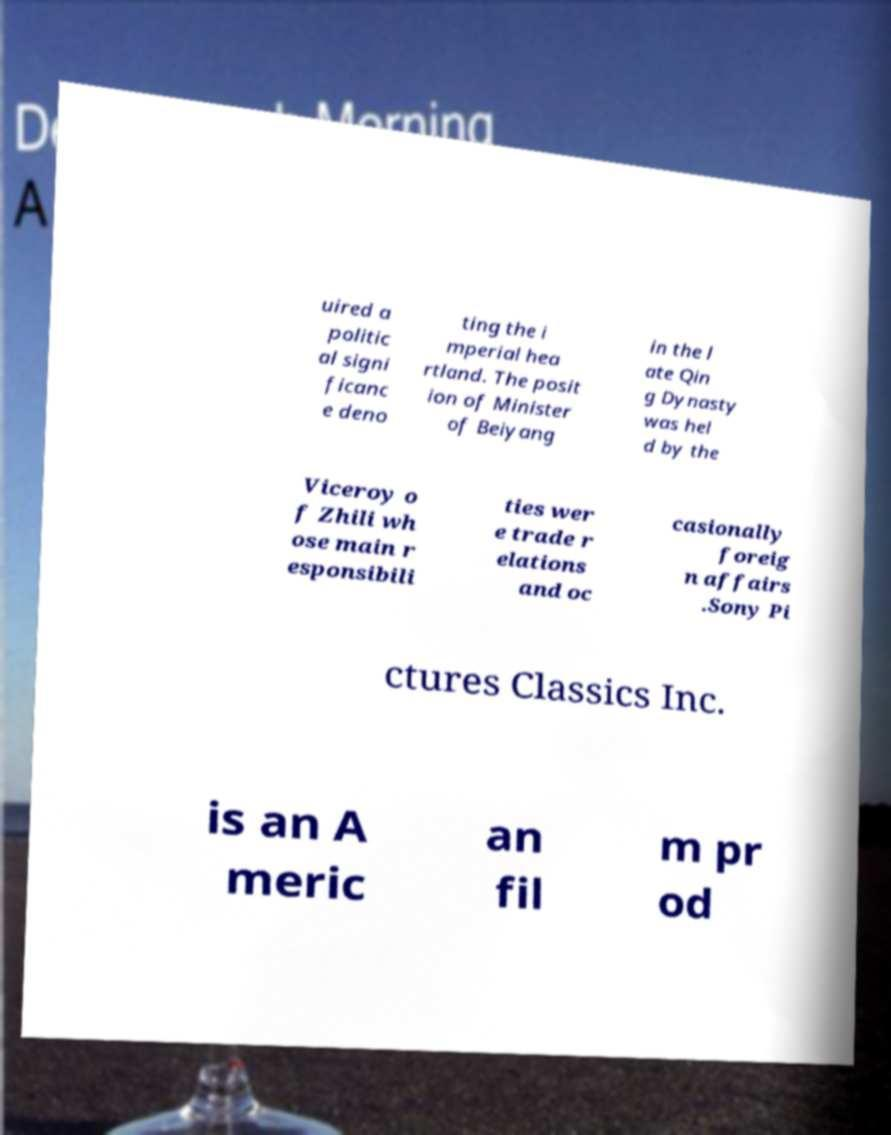What messages or text are displayed in this image? I need them in a readable, typed format. uired a politic al signi ficanc e deno ting the i mperial hea rtland. The posit ion of Minister of Beiyang in the l ate Qin g Dynasty was hel d by the Viceroy o f Zhili wh ose main r esponsibili ties wer e trade r elations and oc casionally foreig n affairs .Sony Pi ctures Classics Inc. is an A meric an fil m pr od 